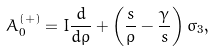<formula> <loc_0><loc_0><loc_500><loc_500>A _ { 0 } ^ { ( + ) } = { I } \frac { d } { d \rho } + \left ( \frac { s } { \rho } - \frac { \gamma } { s } \right ) \sigma _ { 3 } ,</formula> 